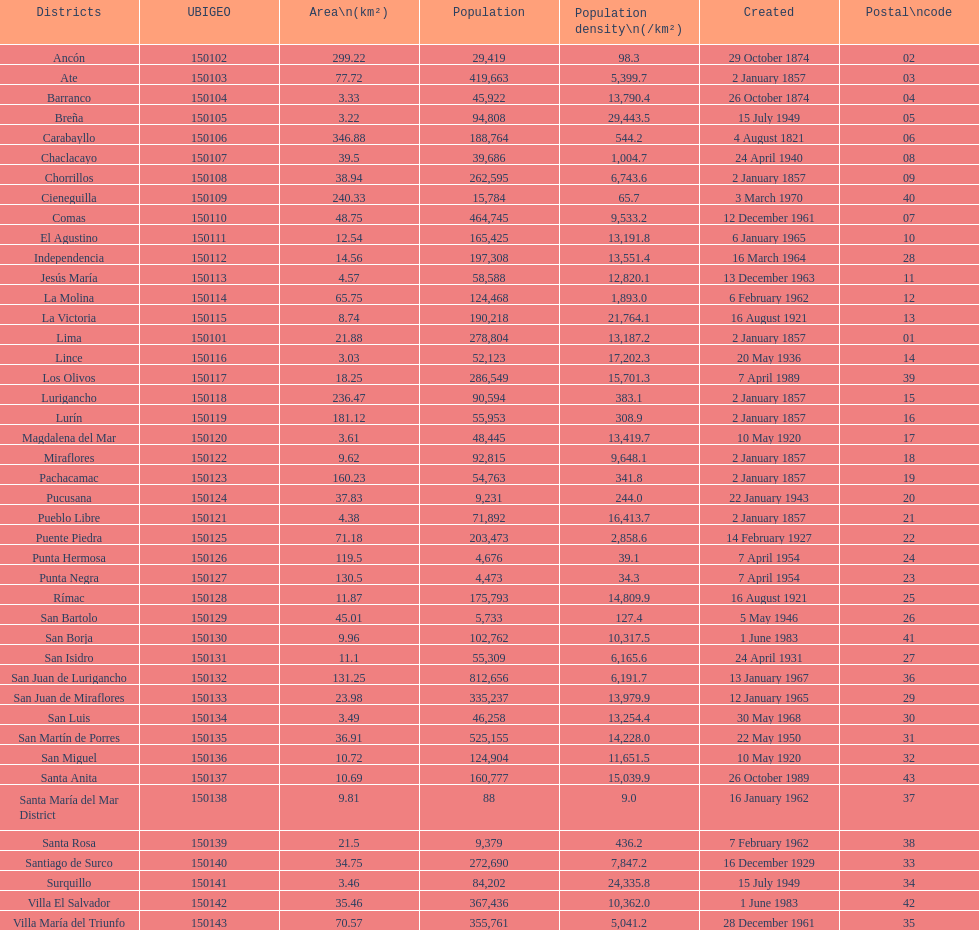How many districts possess a population density equal to or greater than 100 31. 